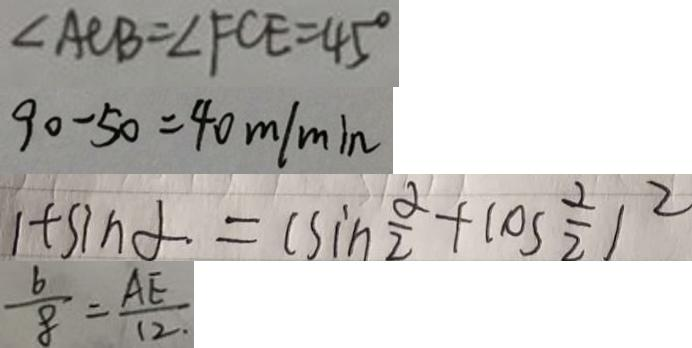<formula> <loc_0><loc_0><loc_500><loc_500>\angle A C B = \angle F C E = 4 5 ^ { \circ } 
 9 0 - 5 0 = 4 0 m / \min 
 1 + \sin \alpha = ( \sin \frac { \alpha } { 2 } + \cos \frac { \alpha } { 2 } ) ^ { 2 } 
 \frac { 6 } { 8 } = \frac { A E } { 1 2 . }</formula> 